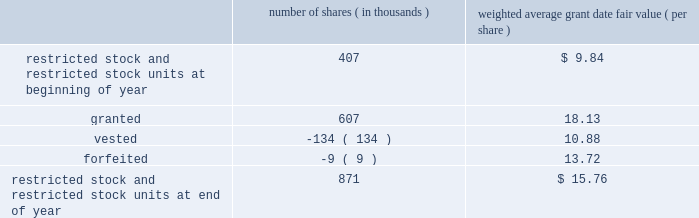Abiomed , inc .
And subsidiaries notes to consolidated financial statements 2014 ( continued ) note 8 .
Stock award plans and stock-based compensation ( continued ) restricted stock and restricted stock units the table summarizes restricted stock and restricted stock unit activity for the fiscal year ended march 31 , 2012 : number of shares ( in thousands ) weighted average grant date fair value ( per share ) .
The remaining unrecognized compensation expense for outstanding restricted stock and restricted stock units , including performance-based awards , as of march 31 , 2012 was $ 7.1 million and the weighted-average period over which this cost will be recognized is 2.2 years .
The weighted average grant-date fair value for restricted stock and restricted stock units granted during the years ended march 31 , 2012 , 2011 , and 2010 was $ 18.13 , $ 10.00 and $ 7.67 per share , respectively .
The total fair value of restricted stock and restricted stock units vested in fiscal years 2012 , 2011 , and 2010 was $ 1.5 million , $ 1.0 million and $ 0.4 million , respectively .
Performance-based awards included in the restricted stock and restricted stock units activity discussed above are certain awards granted in fiscal years 2012 , 2011 and 2010 that vest subject to certain performance-based criteria .
In june 2010 , 311000 shares of restricted stock and a performance-based award for the potential issuance of 45000 shares of common stock were issued to certain executive officers and members of senior management of the company , all of which would vest upon achievement of prescribed service milestones by the award recipients and performance milestones by the company .
During the year ended march 31 , 2011 , the company determined that it met the prescribed performance targets and a portion of these shares and stock options vested .
The remaining shares will vest upon satisfaction of prescribed service conditions by the award recipients .
During the three months ended june 30 , 2011 , the company determined that it should have been using the graded vesting method instead of the straight-line method to expense stock-based compensation for the performance-based awards issued in june 2010 .
This resulted in additional stock based compensation expense of approximately $ 0.6 million being recorded during the three months ended june 30 , 2011 that should have been recorded during the year ended march 31 , 2011 .
The company believes that the amount is not material to its march 31 , 2011 consolidated financial statements and therefore recorded the adjustment in the quarter ended june 30 , 2011 .
During the three months ended june 30 , 2011 , performance-based awards of restricted stock units for the potential issuance of 284000 shares of common stock were issued to certain executive officers and members of the senior management , all of which would vest upon achievement of prescribed service milestones by the award recipients and revenue performance milestones by the company .
As of march 31 , 2012 , the company determined that it met the prescribed targets for 184000 shares underlying these awards and it believes it is probable that the prescribed performance targets will be met for the remaining 100000 shares , and the compensation expense is being recognized accordingly .
During the year ended march 31 , 2012 , the company has recorded $ 3.3 million in stock-based compensation expense for equity awards in which the prescribed performance milestones have been achieved or are probable of being achieved .
The remaining unrecognized compensation expense related to these equity awards at march 31 , 2012 is $ 3.6 million based on the company 2019s current assessment of probability of achieving the performance milestones .
The weighted-average period over which this cost will be recognized is 2.1 years. .
For equity awards where the performance criteria has been met in 2012 , what is the average compensation expense per year over which the cost will be expensed? 
Computations: ((3.6 * 1000000) / 2.1)
Answer: 1714285.71429. 